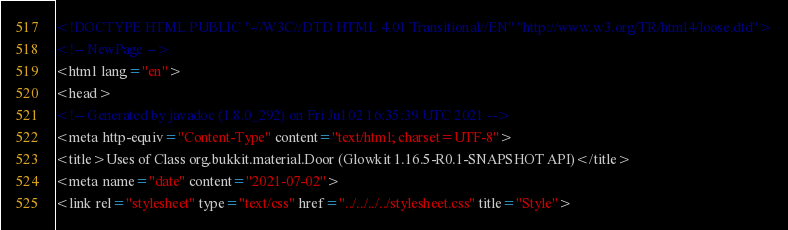<code> <loc_0><loc_0><loc_500><loc_500><_HTML_><!DOCTYPE HTML PUBLIC "-//W3C//DTD HTML 4.01 Transitional//EN" "http://www.w3.org/TR/html4/loose.dtd">
<!-- NewPage -->
<html lang="en">
<head>
<!-- Generated by javadoc (1.8.0_292) on Fri Jul 02 16:35:39 UTC 2021 -->
<meta http-equiv="Content-Type" content="text/html; charset=UTF-8">
<title>Uses of Class org.bukkit.material.Door (Glowkit 1.16.5-R0.1-SNAPSHOT API)</title>
<meta name="date" content="2021-07-02">
<link rel="stylesheet" type="text/css" href="../../../../stylesheet.css" title="Style"></code> 